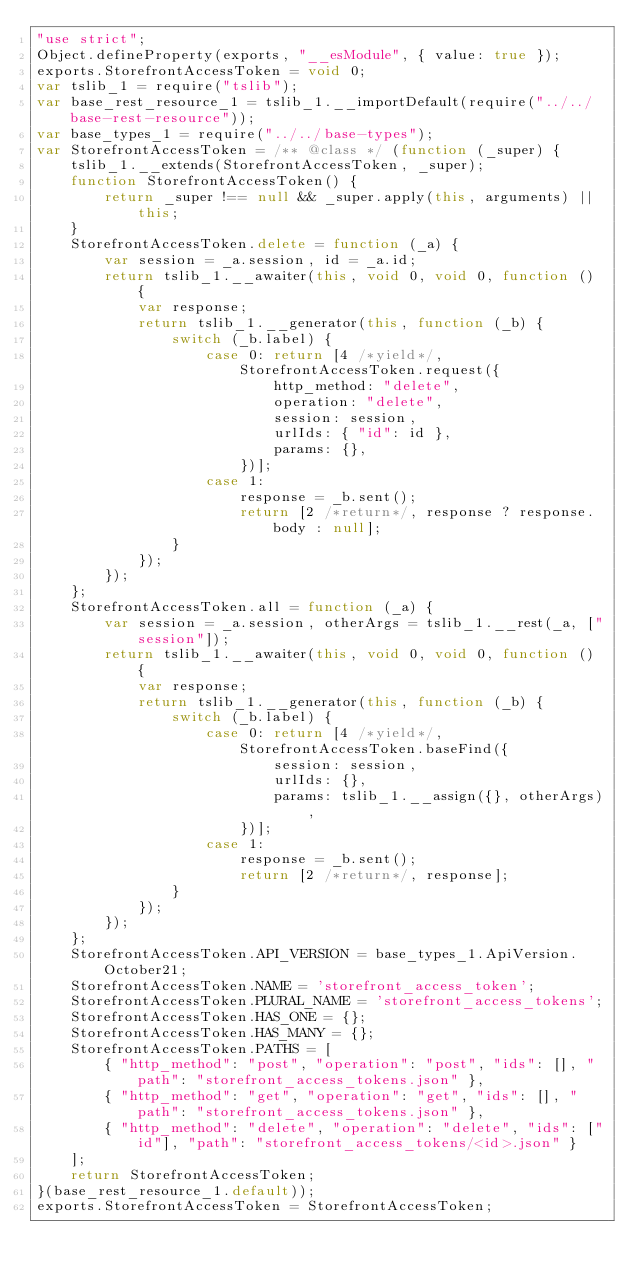Convert code to text. <code><loc_0><loc_0><loc_500><loc_500><_JavaScript_>"use strict";
Object.defineProperty(exports, "__esModule", { value: true });
exports.StorefrontAccessToken = void 0;
var tslib_1 = require("tslib");
var base_rest_resource_1 = tslib_1.__importDefault(require("../../base-rest-resource"));
var base_types_1 = require("../../base-types");
var StorefrontAccessToken = /** @class */ (function (_super) {
    tslib_1.__extends(StorefrontAccessToken, _super);
    function StorefrontAccessToken() {
        return _super !== null && _super.apply(this, arguments) || this;
    }
    StorefrontAccessToken.delete = function (_a) {
        var session = _a.session, id = _a.id;
        return tslib_1.__awaiter(this, void 0, void 0, function () {
            var response;
            return tslib_1.__generator(this, function (_b) {
                switch (_b.label) {
                    case 0: return [4 /*yield*/, StorefrontAccessToken.request({
                            http_method: "delete",
                            operation: "delete",
                            session: session,
                            urlIds: { "id": id },
                            params: {},
                        })];
                    case 1:
                        response = _b.sent();
                        return [2 /*return*/, response ? response.body : null];
                }
            });
        });
    };
    StorefrontAccessToken.all = function (_a) {
        var session = _a.session, otherArgs = tslib_1.__rest(_a, ["session"]);
        return tslib_1.__awaiter(this, void 0, void 0, function () {
            var response;
            return tslib_1.__generator(this, function (_b) {
                switch (_b.label) {
                    case 0: return [4 /*yield*/, StorefrontAccessToken.baseFind({
                            session: session,
                            urlIds: {},
                            params: tslib_1.__assign({}, otherArgs),
                        })];
                    case 1:
                        response = _b.sent();
                        return [2 /*return*/, response];
                }
            });
        });
    };
    StorefrontAccessToken.API_VERSION = base_types_1.ApiVersion.October21;
    StorefrontAccessToken.NAME = 'storefront_access_token';
    StorefrontAccessToken.PLURAL_NAME = 'storefront_access_tokens';
    StorefrontAccessToken.HAS_ONE = {};
    StorefrontAccessToken.HAS_MANY = {};
    StorefrontAccessToken.PATHS = [
        { "http_method": "post", "operation": "post", "ids": [], "path": "storefront_access_tokens.json" },
        { "http_method": "get", "operation": "get", "ids": [], "path": "storefront_access_tokens.json" },
        { "http_method": "delete", "operation": "delete", "ids": ["id"], "path": "storefront_access_tokens/<id>.json" }
    ];
    return StorefrontAccessToken;
}(base_rest_resource_1.default));
exports.StorefrontAccessToken = StorefrontAccessToken;
</code> 